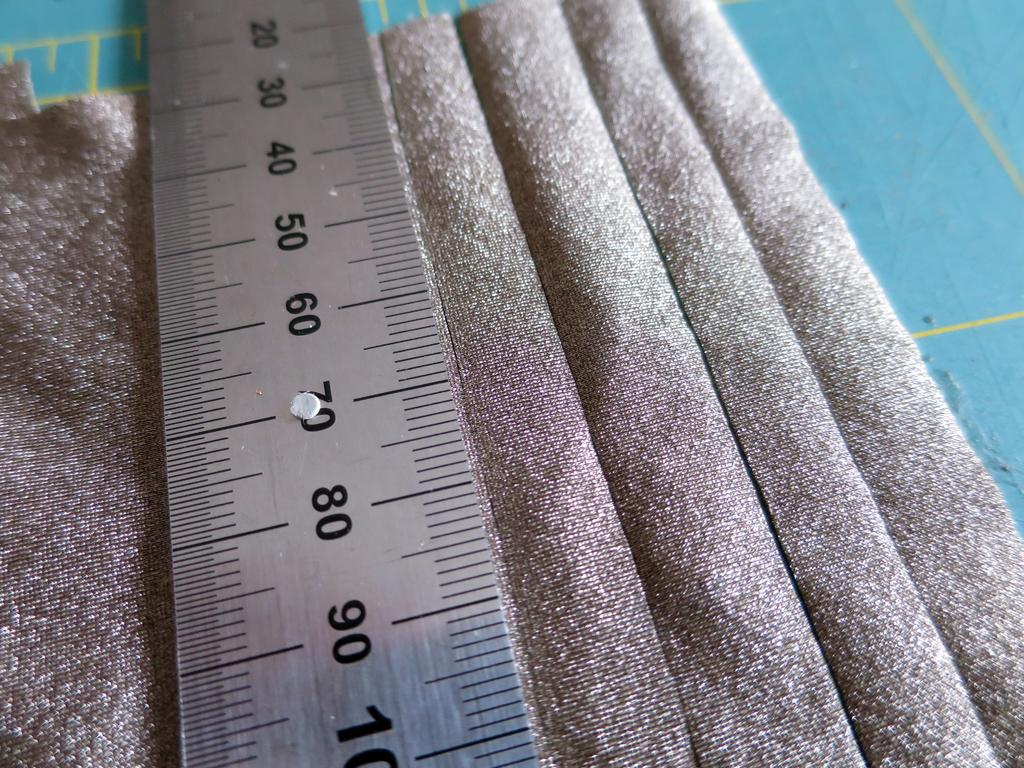<image>
Write a terse but informative summary of the picture. Some silver mesh fabric has a ruler laying on top of it from 20 to 100 centimeters. 